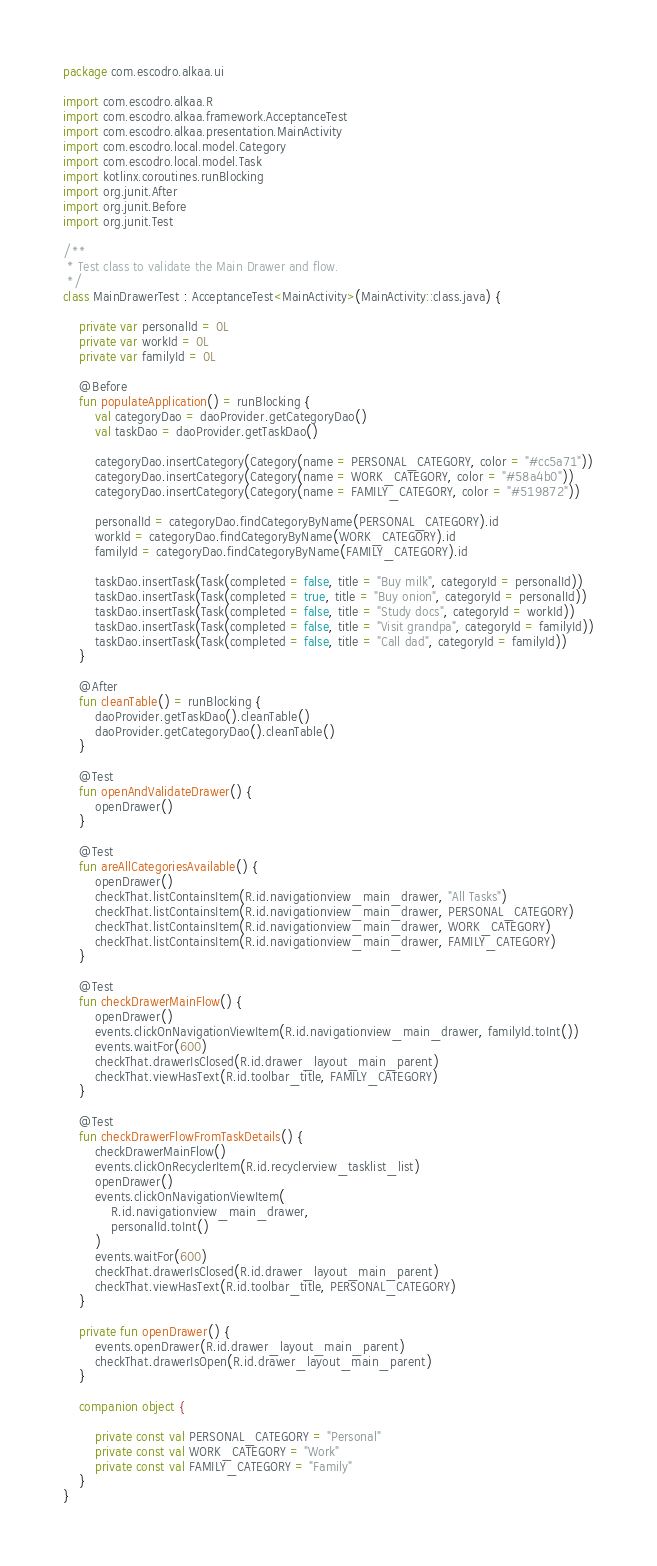<code> <loc_0><loc_0><loc_500><loc_500><_Kotlin_>package com.escodro.alkaa.ui

import com.escodro.alkaa.R
import com.escodro.alkaa.framework.AcceptanceTest
import com.escodro.alkaa.presentation.MainActivity
import com.escodro.local.model.Category
import com.escodro.local.model.Task
import kotlinx.coroutines.runBlocking
import org.junit.After
import org.junit.Before
import org.junit.Test

/**
 * Test class to validate the Main Drawer and flow.
 */
class MainDrawerTest : AcceptanceTest<MainActivity>(MainActivity::class.java) {

    private var personalId = 0L
    private var workId = 0L
    private var familyId = 0L

    @Before
    fun populateApplication() = runBlocking {
        val categoryDao = daoProvider.getCategoryDao()
        val taskDao = daoProvider.getTaskDao()

        categoryDao.insertCategory(Category(name = PERSONAL_CATEGORY, color = "#cc5a71"))
        categoryDao.insertCategory(Category(name = WORK_CATEGORY, color = "#58a4b0"))
        categoryDao.insertCategory(Category(name = FAMILY_CATEGORY, color = "#519872"))

        personalId = categoryDao.findCategoryByName(PERSONAL_CATEGORY).id
        workId = categoryDao.findCategoryByName(WORK_CATEGORY).id
        familyId = categoryDao.findCategoryByName(FAMILY_CATEGORY).id

        taskDao.insertTask(Task(completed = false, title = "Buy milk", categoryId = personalId))
        taskDao.insertTask(Task(completed = true, title = "Buy onion", categoryId = personalId))
        taskDao.insertTask(Task(completed = false, title = "Study docs", categoryId = workId))
        taskDao.insertTask(Task(completed = false, title = "Visit grandpa", categoryId = familyId))
        taskDao.insertTask(Task(completed = false, title = "Call dad", categoryId = familyId))
    }

    @After
    fun cleanTable() = runBlocking {
        daoProvider.getTaskDao().cleanTable()
        daoProvider.getCategoryDao().cleanTable()
    }

    @Test
    fun openAndValidateDrawer() {
        openDrawer()
    }

    @Test
    fun areAllCategoriesAvailable() {
        openDrawer()
        checkThat.listContainsItem(R.id.navigationview_main_drawer, "All Tasks")
        checkThat.listContainsItem(R.id.navigationview_main_drawer, PERSONAL_CATEGORY)
        checkThat.listContainsItem(R.id.navigationview_main_drawer, WORK_CATEGORY)
        checkThat.listContainsItem(R.id.navigationview_main_drawer, FAMILY_CATEGORY)
    }

    @Test
    fun checkDrawerMainFlow() {
        openDrawer()
        events.clickOnNavigationViewItem(R.id.navigationview_main_drawer, familyId.toInt())
        events.waitFor(600)
        checkThat.drawerIsClosed(R.id.drawer_layout_main_parent)
        checkThat.viewHasText(R.id.toolbar_title, FAMILY_CATEGORY)
    }

    @Test
    fun checkDrawerFlowFromTaskDetails() {
        checkDrawerMainFlow()
        events.clickOnRecyclerItem(R.id.recyclerview_tasklist_list)
        openDrawer()
        events.clickOnNavigationViewItem(
            R.id.navigationview_main_drawer,
            personalId.toInt()
        )
        events.waitFor(600)
        checkThat.drawerIsClosed(R.id.drawer_layout_main_parent)
        checkThat.viewHasText(R.id.toolbar_title, PERSONAL_CATEGORY)
    }

    private fun openDrawer() {
        events.openDrawer(R.id.drawer_layout_main_parent)
        checkThat.drawerIsOpen(R.id.drawer_layout_main_parent)
    }

    companion object {

        private const val PERSONAL_CATEGORY = "Personal"
        private const val WORK_CATEGORY = "Work"
        private const val FAMILY_CATEGORY = "Family"
    }
}
</code> 